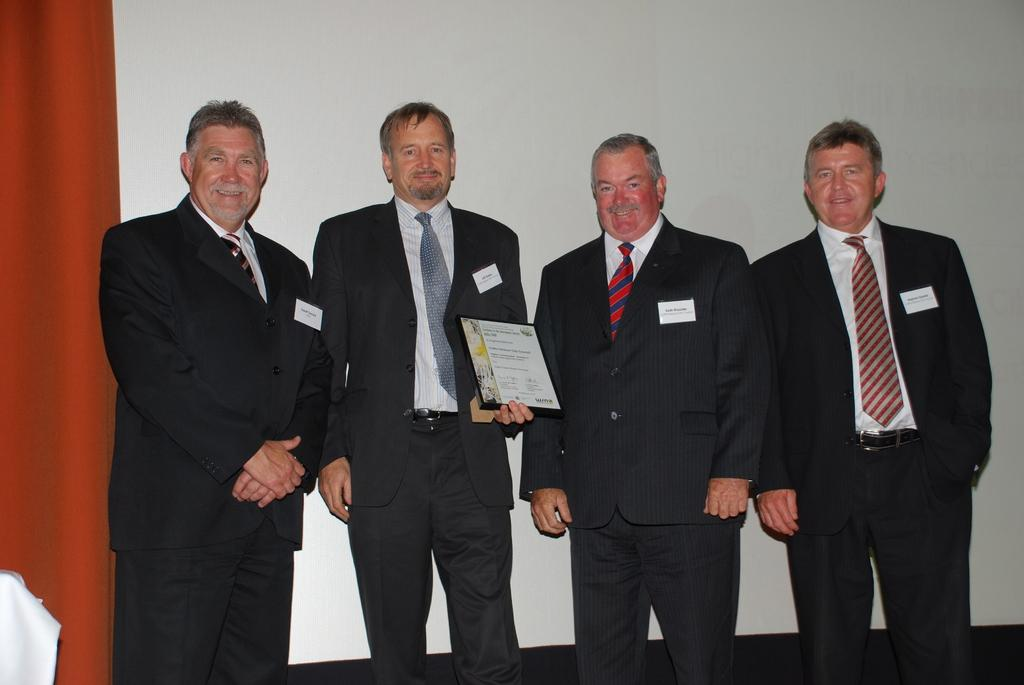How many people are present in the image? There are four people in the image. What are the people wearing? All four people are wearing suits. Can you describe any specific actions or objects being held by one of the people? One person is holding a card in his hand. What is the temperature of the town in the image? There is no town present in the image, so it is not possible to determine the temperature. How many pages are visible in the image? There are no pages present in the image. 